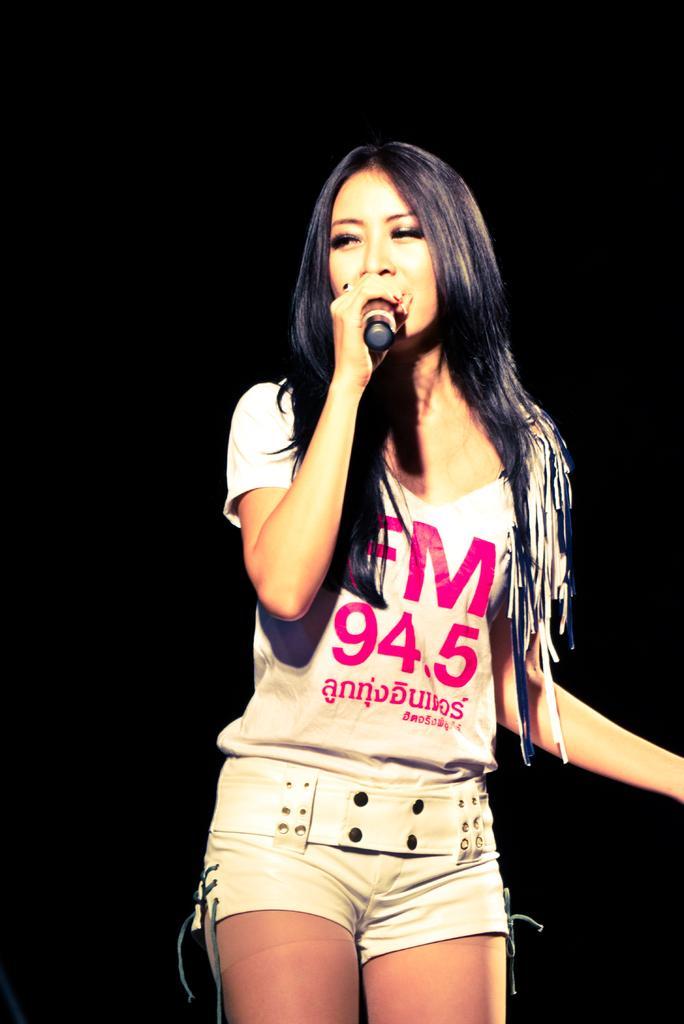In one or two sentences, can you explain what this image depicts? Girl holding a mic wearing shorts. 